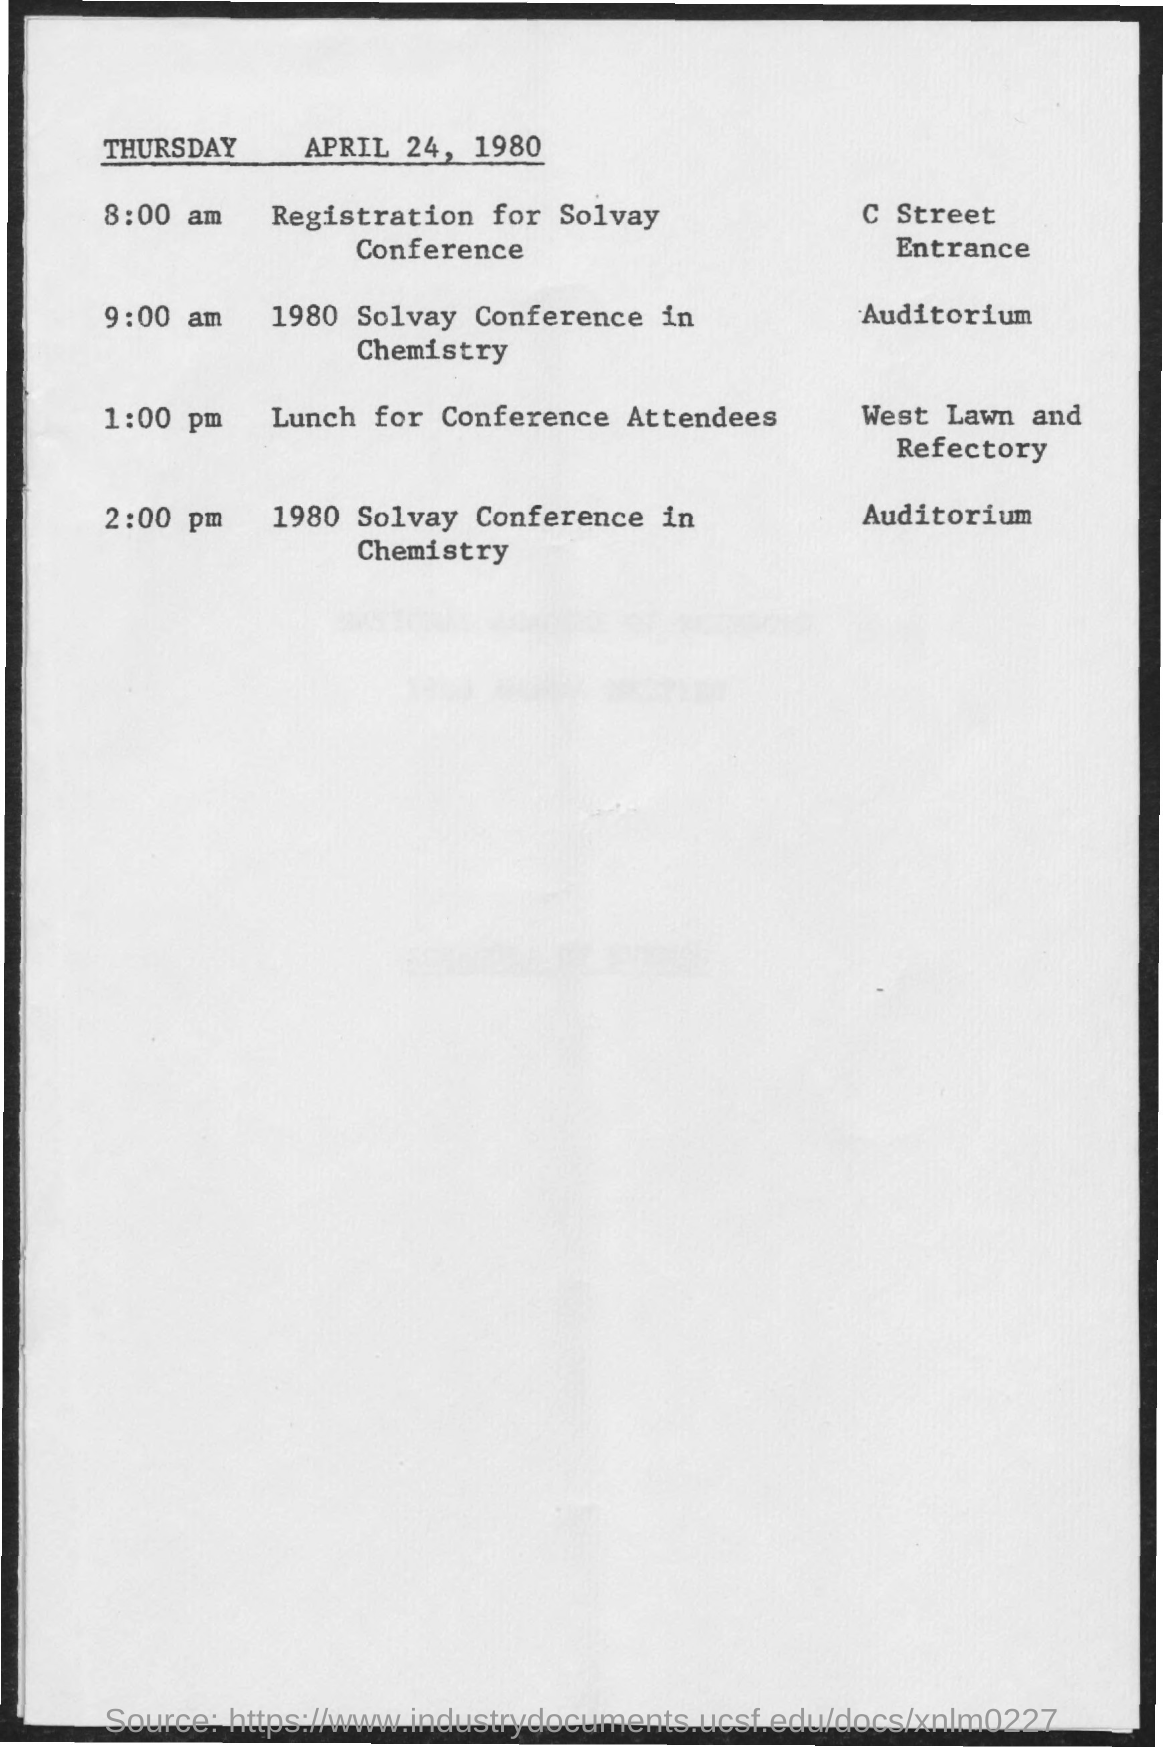Highlight a few significant elements in this photo. At 8:00 am, the schedule for the Solvay conference will be known. The scheduled time for lunch for conference attendees is 1:00 pm. At 9:00 am on the day of the 1980 Solvay Conference in Chemistry, the schedule was as follows: 